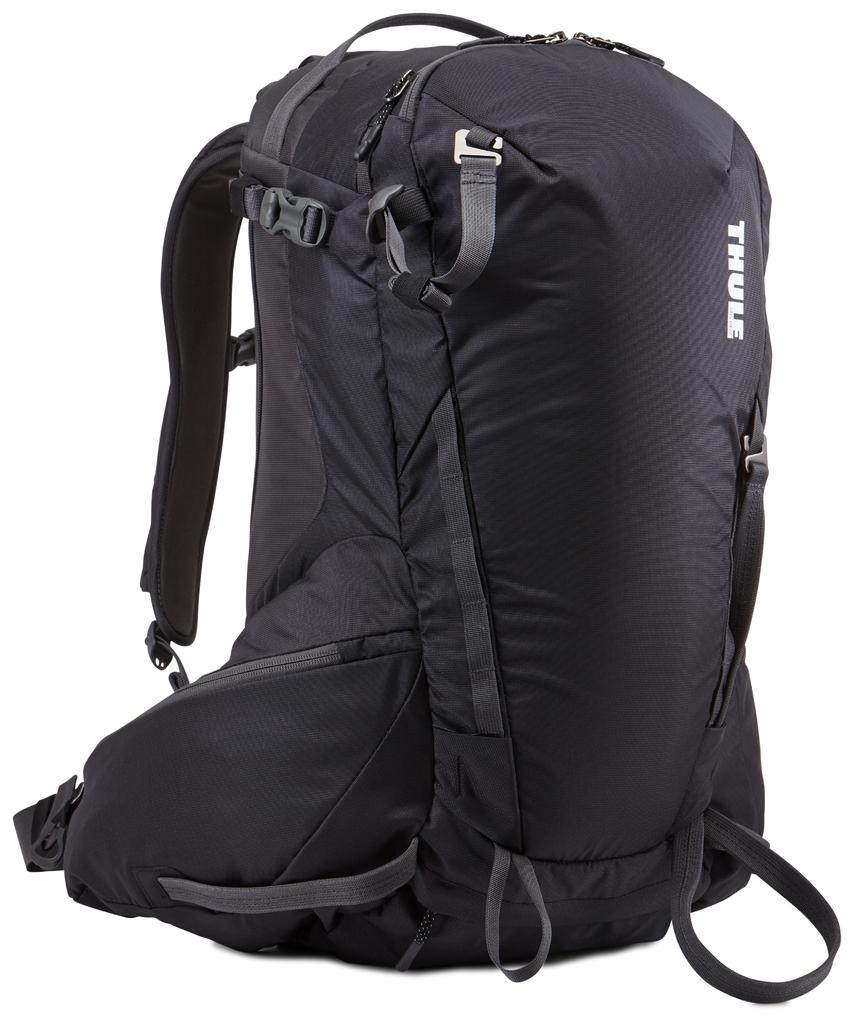<image>
Offer a succinct explanation of the picture presented. A product shot of a black Thule backpack. 